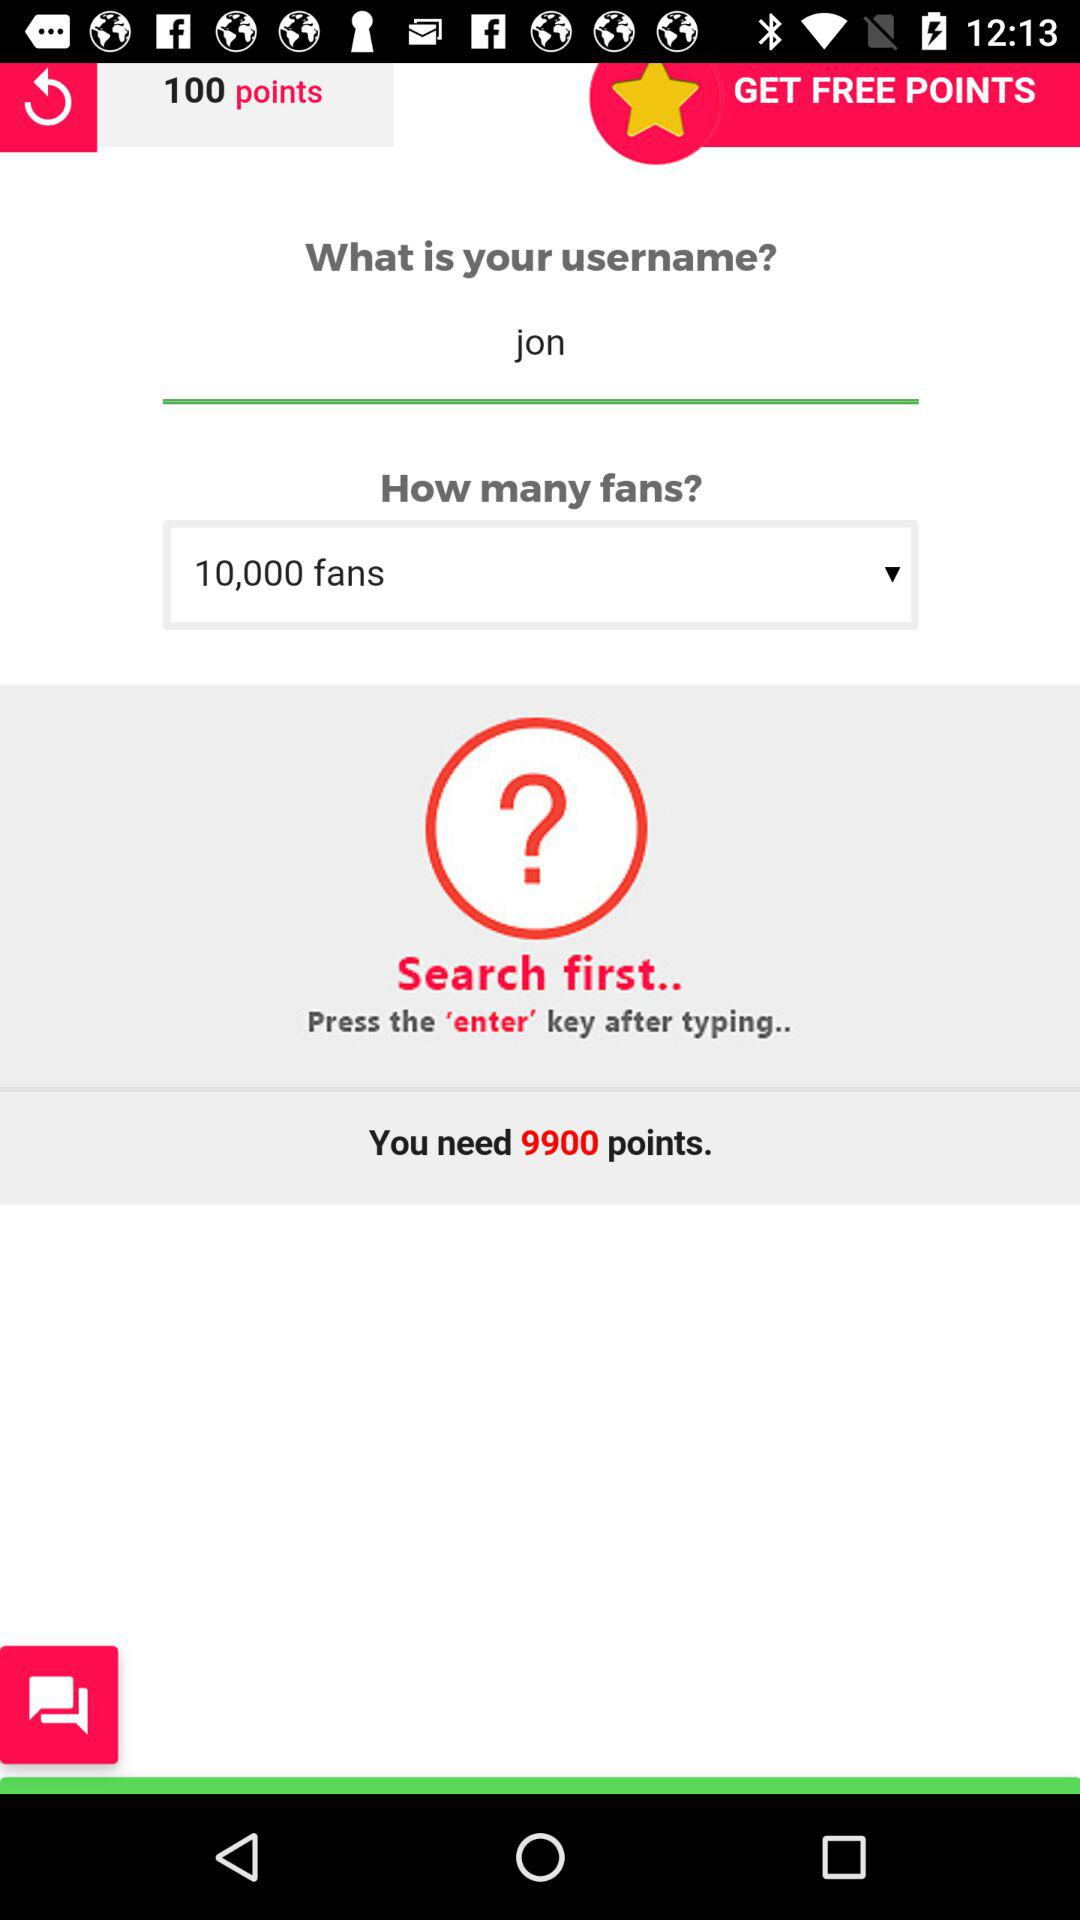How many fans are there? There are 10,000 fans. 